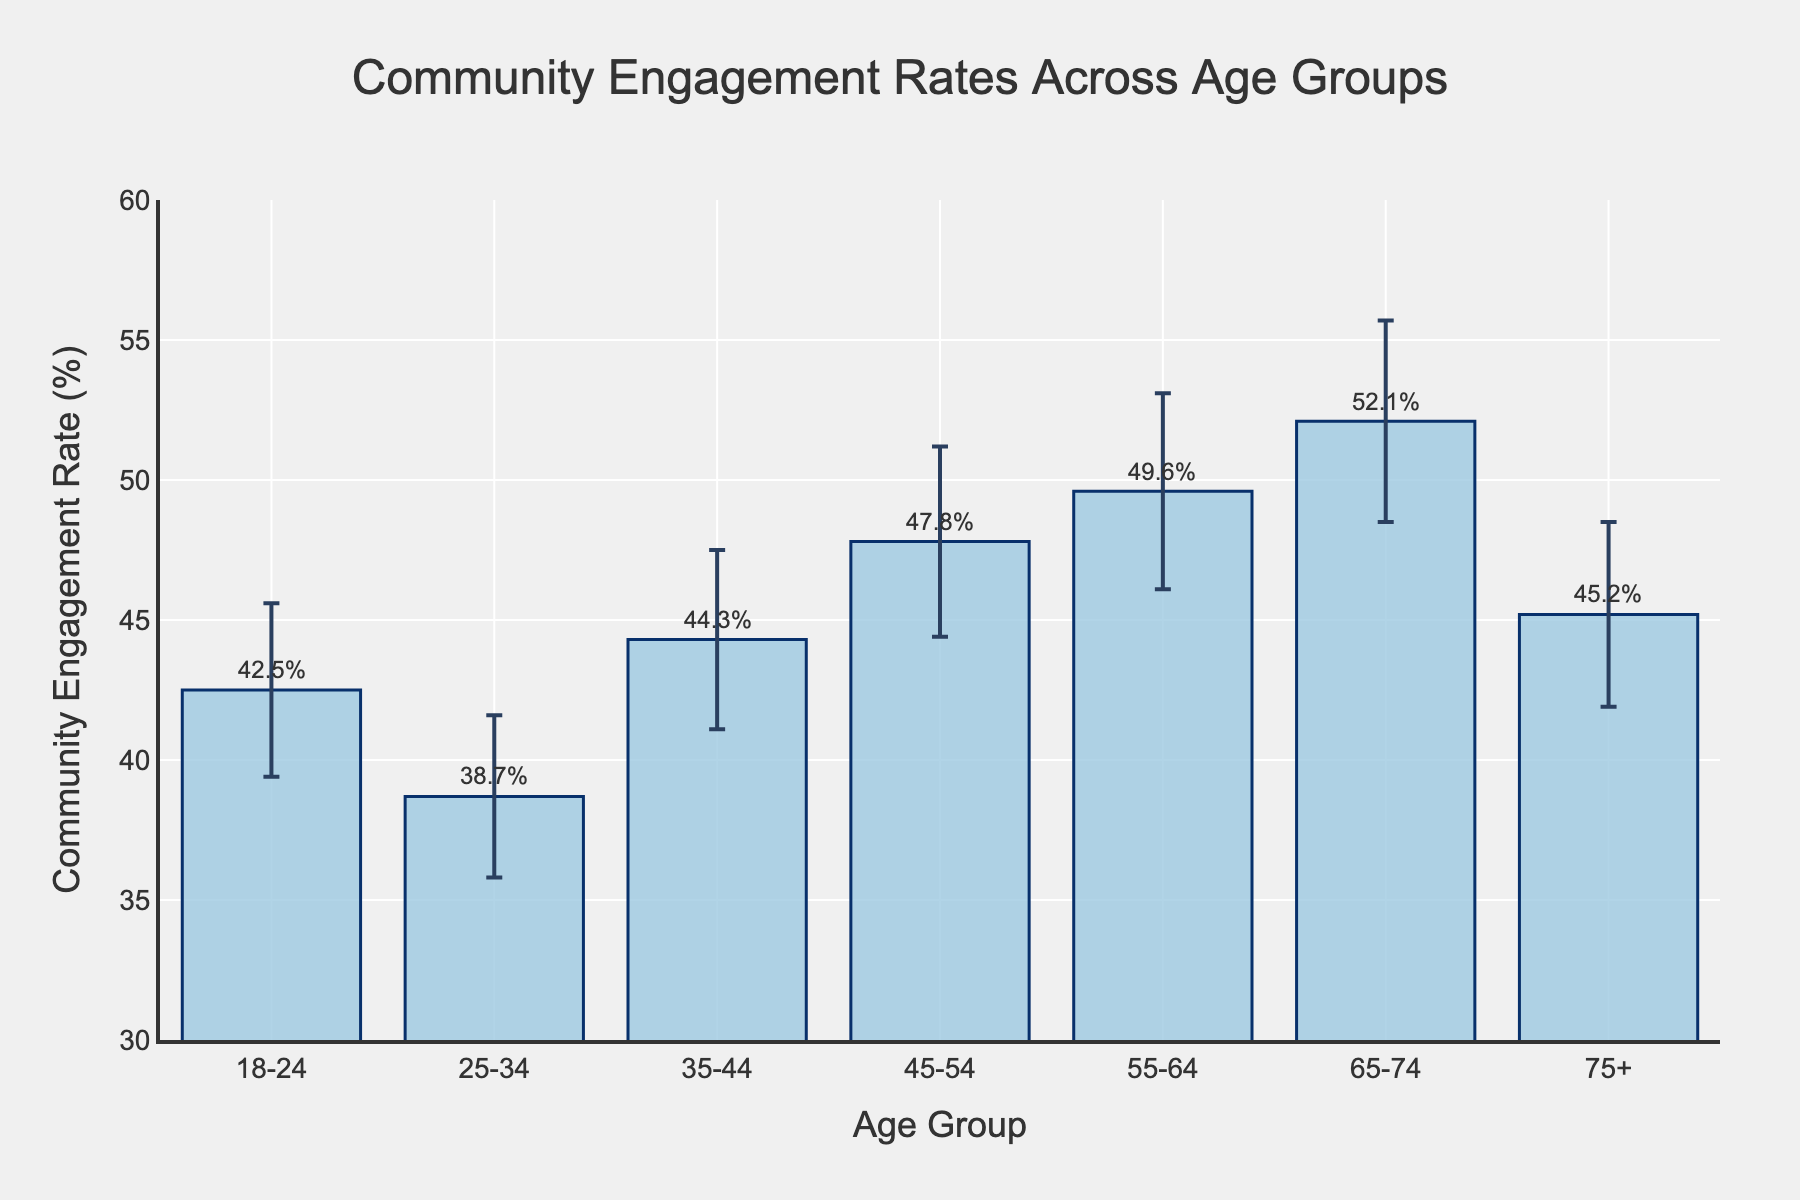What is the title of the bar chart? The title is usually at the top of the chart. For this bar chart, the title is displayed as "Community Engagement Rates Across Age Groups".
Answer: Community Engagement Rates Across Age Groups Which age group has the highest community engagement rate? By examining the heights of the bars, we see that the age group 65-74 has the tallest bar, indicating it has the highest community engagement rate.
Answer: 65-74 What is the community engagement rate for the age group 55-64? We need to look at the bar corresponding to the age group 55-64 and find the label or annotation near the top of the bar, which shows the community engagement rate is 49.6%.
Answer: 49.6% How many age groups are represented in the chart? Count the number of bars along the x-axis, each representing a distinct age group. There are 7 age groups in total.
Answer: 7 What is the range of the y-axis? Examine the labels on the y-axis; the lowest value begins at 30%, and the highest value extends up to 60%.
Answer: 30-60% Which age group has the lowest community engagement rate, and what is that rate? Identify the shortest bar, which corresponds to the age group 25-34, with a community engagement rate of 38.7%.
Answer: 25-34, 38.7% What is the difference in community engagement rates between the age groups 18-24 and 25-34? Subtract the rate of the 25-34 age group (38.7) from the rate of the 18-24 age group (42.5): 42.5% - 38.7% = 3.8%.
Answer: 3.8% Identify the age group with a community engagement rate of 45.2%. Locate the bar annotated with 45.2%, which corresponds to the age group 75+.
Answer: 75+ Which age groups have community engagement rates within the margin of 44% to 48%? Look for bars that fall within this range on the y-axis: 35-44, 45-54, and 75+.
Answer: 35-44, 45-54, 75+ Compare the engagement rates of the age groups 45-54 and 75+. Which one is higher, and by how much? The rate for 45-54 is 47.8%, and for 75+ it is 45.2%. Find the difference: 47.8% - 45.2% = 2.6%.
Answer: 45-54 is higher by 2.6% 